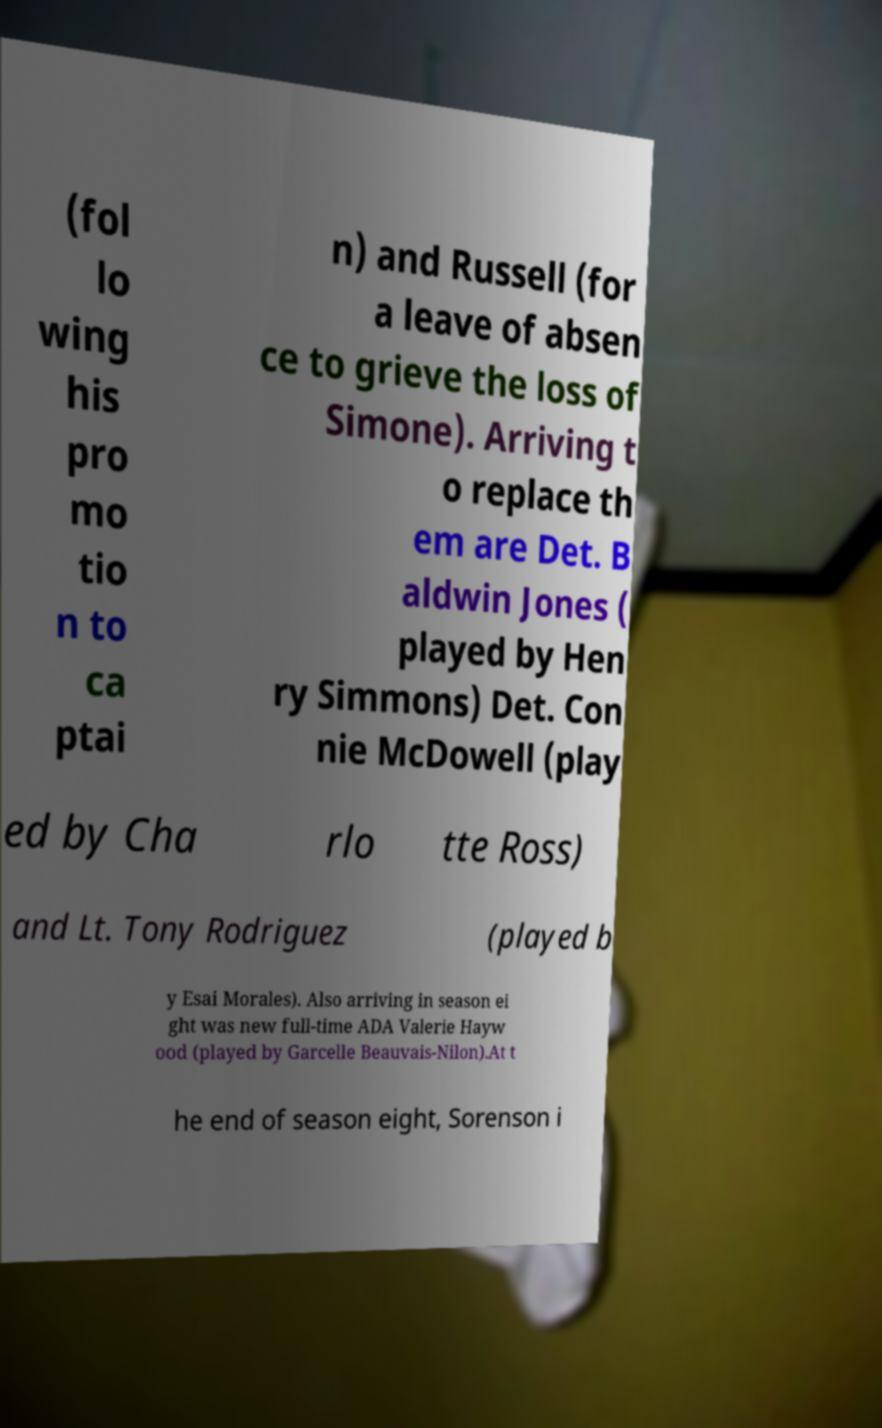Could you assist in decoding the text presented in this image and type it out clearly? (fol lo wing his pro mo tio n to ca ptai n) and Russell (for a leave of absen ce to grieve the loss of Simone). Arriving t o replace th em are Det. B aldwin Jones ( played by Hen ry Simmons) Det. Con nie McDowell (play ed by Cha rlo tte Ross) and Lt. Tony Rodriguez (played b y Esai Morales). Also arriving in season ei ght was new full-time ADA Valerie Hayw ood (played by Garcelle Beauvais-Nilon).At t he end of season eight, Sorenson i 